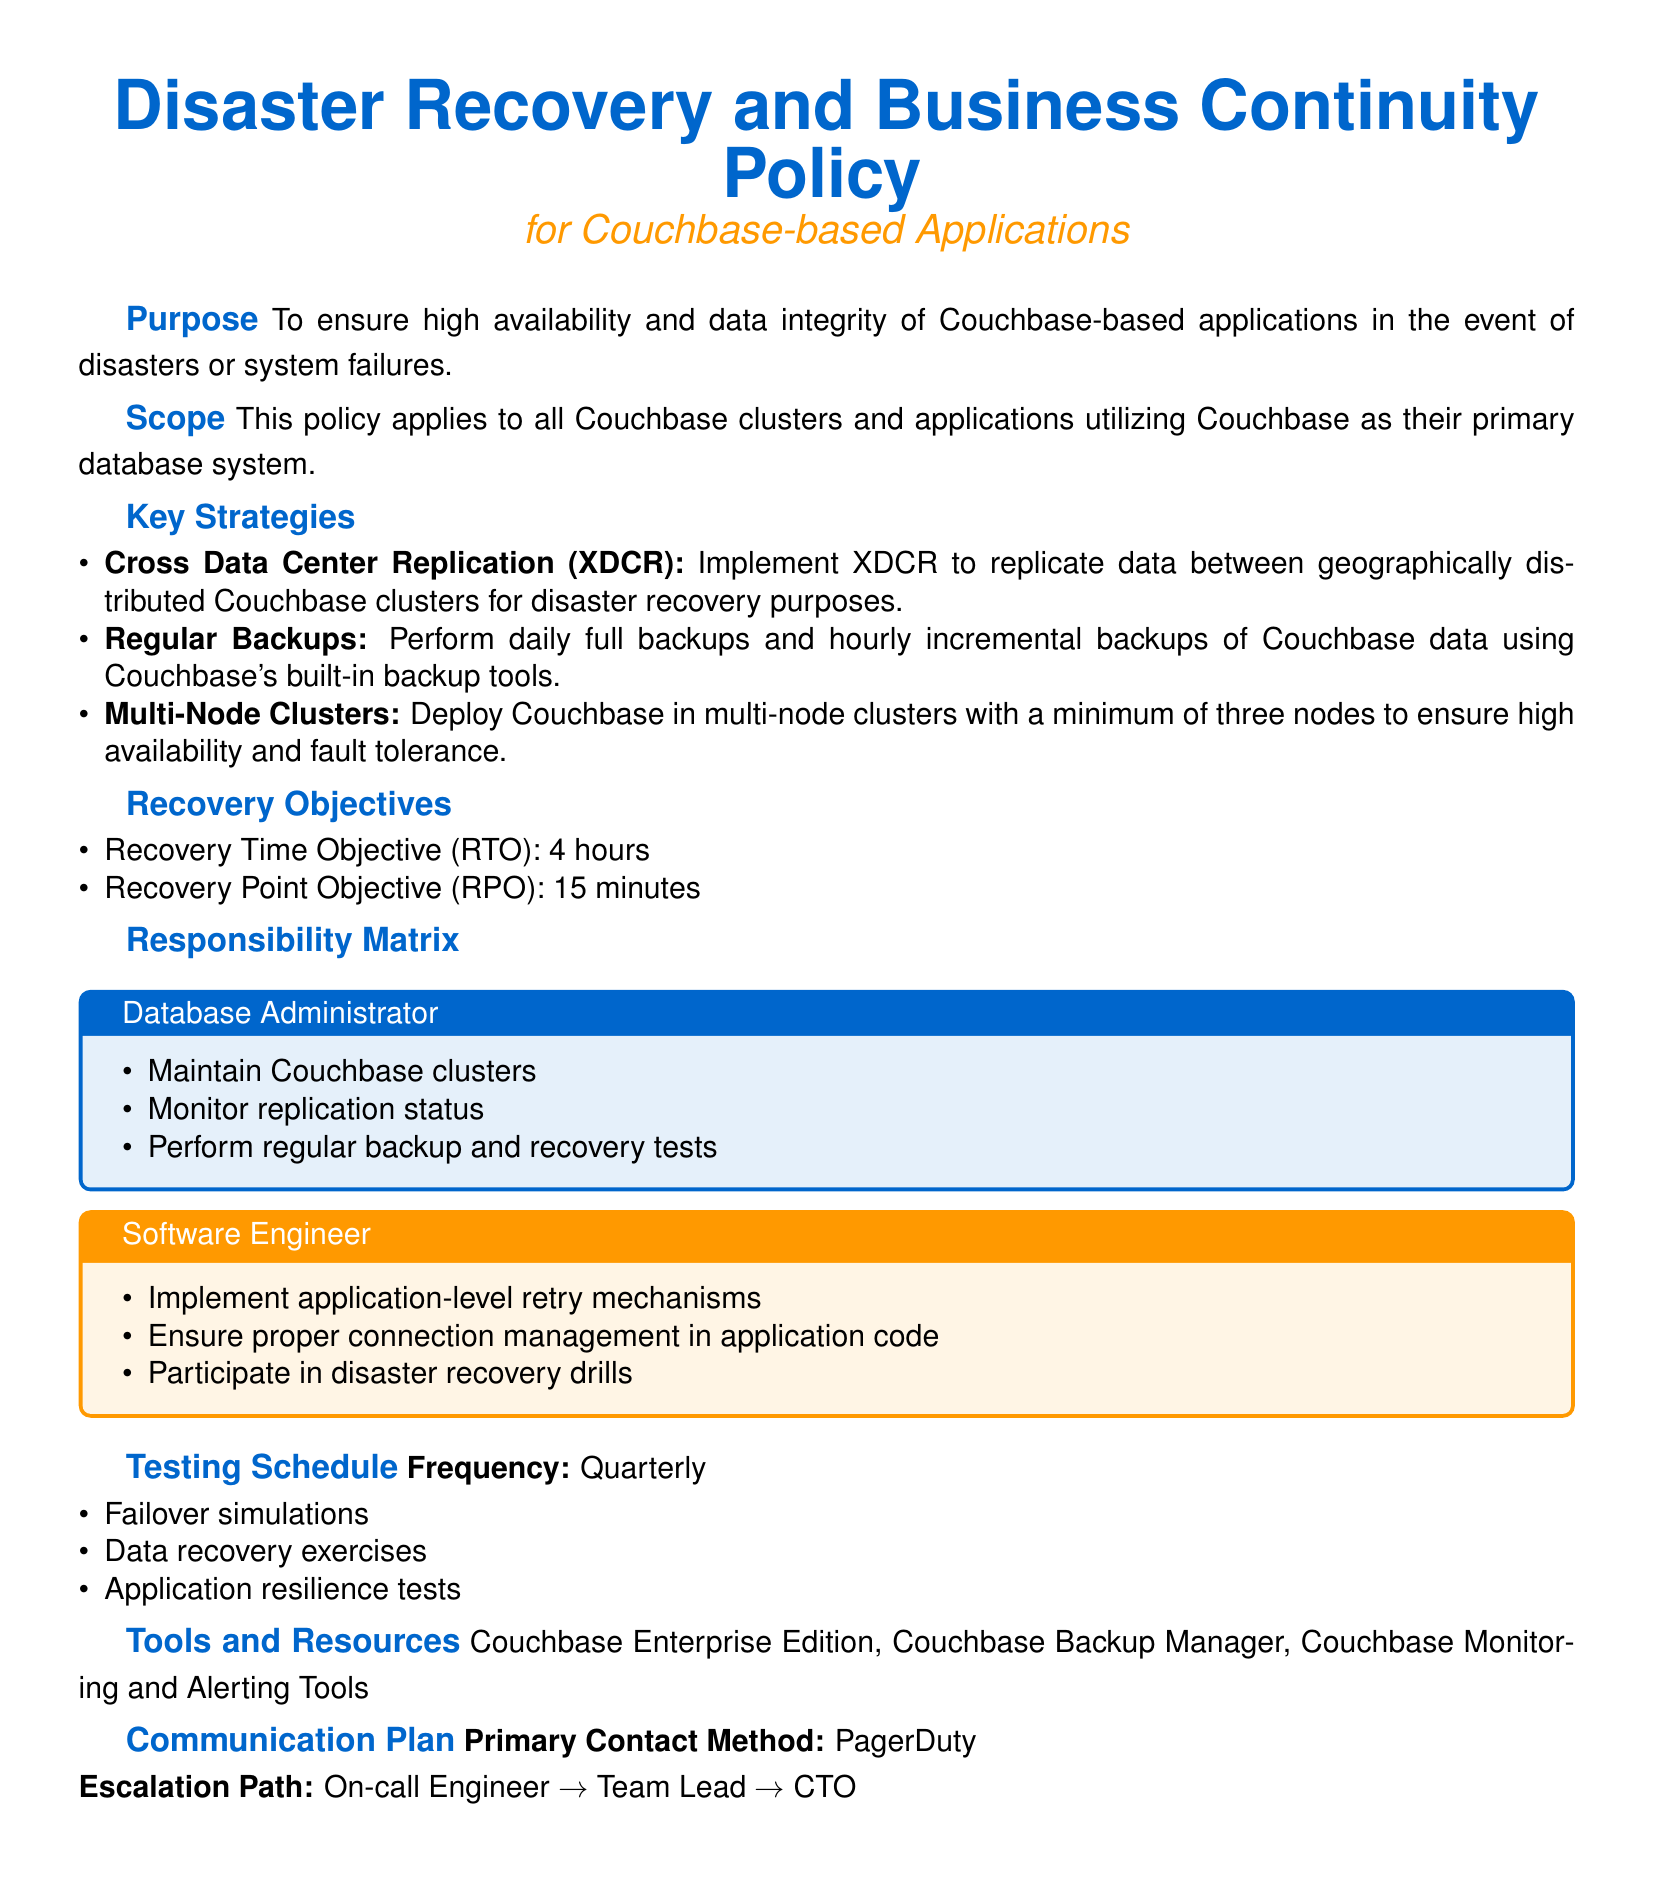What is the purpose of the policy? The purpose is to ensure high availability and data integrity of Couchbase-based applications in the event of disasters or system failures.
Answer: High availability and data integrity What is the Recovery Time Objective (RTO)? The Recovery Time Objective is specified in the document as the time it takes to recover from a disaster.
Answer: 4 hours What type of replication is used for disaster recovery? The document specifies a method for data replication aimed at disaster recovery.
Answer: Cross Data Center Replication (XDCR) How often should backups be performed? The document provides specific guidance on the frequency of backups for Couchbase data.
Answer: Daily full backups and hourly incremental backups Who is responsible for monitoring replication status? The document includes a responsibility matrix that identifies who is accountable for monitoring replication.
Answer: Database Administrator What is the frequency of the testing schedule? The testing schedule indicates how often drills and tests should be conducted as part of the policy.
Answer: Quarterly What is the Primary Contact Method for the communication plan? The communication plan outlines the primary method of contact in the event of an incident.
Answer: PagerDuty What are the minimum nodes required for a multi-node cluster? The document mentions the structure of the cluster needed for fault tolerance.
Answer: Three nodes What exercises are included in the testing schedule? The testing schedule lists specific types of exercises performed to ensure system resilience.
Answer: Failover simulations What is the Escalation Path in the event of an incident? The communication plan details the hierarchy for escalation during incidents.
Answer: On-call Engineer → Team Lead → CTO 